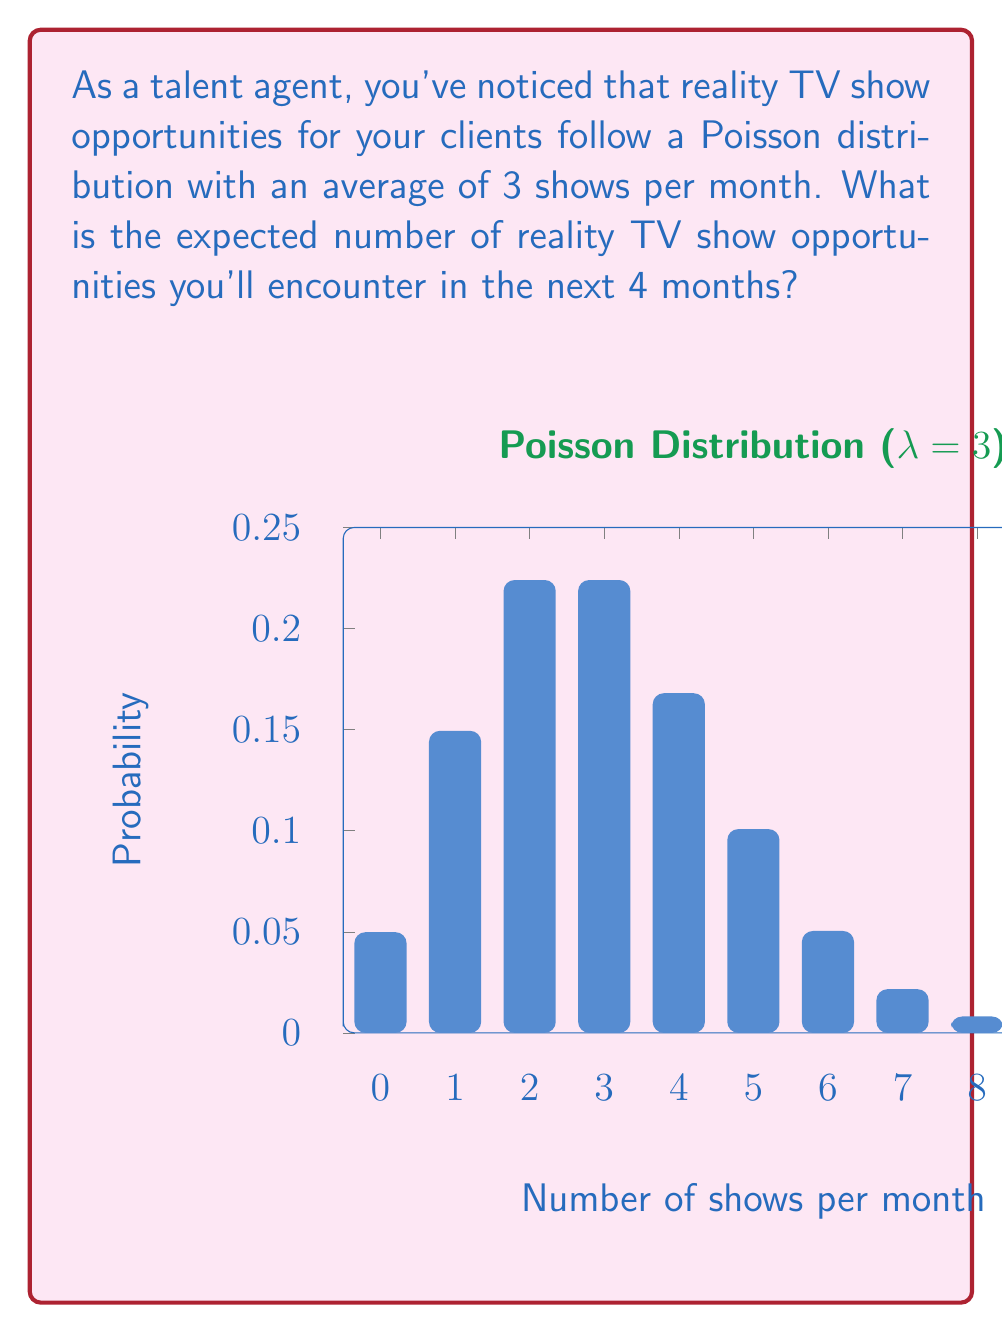Can you answer this question? Let's approach this step-by-step:

1) The Poisson distribution is given by the formula:

   $$P(X = k) = \frac{e^{-\lambda}\lambda^k}{k!}$$

   where $\lambda$ is the average rate of occurrence.

2) In this case, $\lambda = 3$ shows per month.

3) For a Poisson distribution, the expected value (mean) is equal to $\lambda$.

4) We're asked about a 4-month period. The linearity of expectation tells us that we can multiply the monthly rate by 4:

   $$E(X_{4\text{ months}}) = 4 \cdot E(X_{1\text{ month}}) = 4 \cdot \lambda$$

5) Substituting our value for $\lambda$:

   $$E(X_{4\text{ months}}) = 4 \cdot 3 = 12$$

Therefore, the expected number of reality TV show opportunities in 4 months is 12.
Answer: 12 shows 